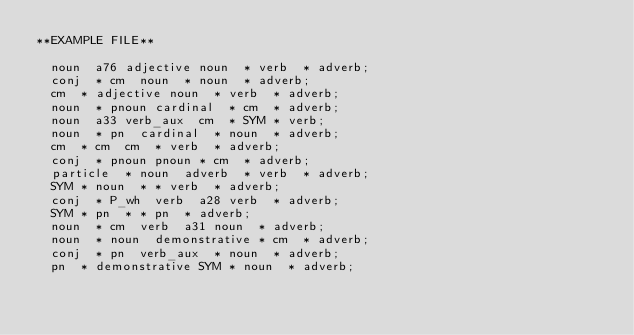Convert code to text. <code><loc_0><loc_0><loc_500><loc_500><_Elixir_>**EXAMPLE FILE**

	noun	a76	adjective	noun	*	verb	*	adverb;
	conj	*	cm	noun	*	noun	*	adverb;
	cm	*	adjective	noun	*	verb	*	adverb;
	noun	*	pnoun	cardinal	*	cm	*	adverb;
	noun	a33	verb_aux	cm	*	SYM	*	verb;
	noun	*	pn	cardinal	*	noun	*	adverb;
	cm	*	cm	cm	*	verb	*	adverb;
	conj	*	pnoun	pnoun	*	cm	*	adverb;
	particle	*	noun	adverb	*	verb	*	adverb;
	SYM	*	noun	*	*	verb	*	adverb;
	conj	*	P_wh	verb	a28	verb	*	adverb;
	SYM	*	pn	*	*	pn	*	adverb;
	noun	*	cm	verb	a31	noun	*	adverb;
	noun	*	noun	demonstrative	*	cm	*	adverb;
	conj	*	pn	verb_aux	*	noun	*	adverb;
	pn	*	demonstrative	SYM	*	noun	*	adverb;
</code> 